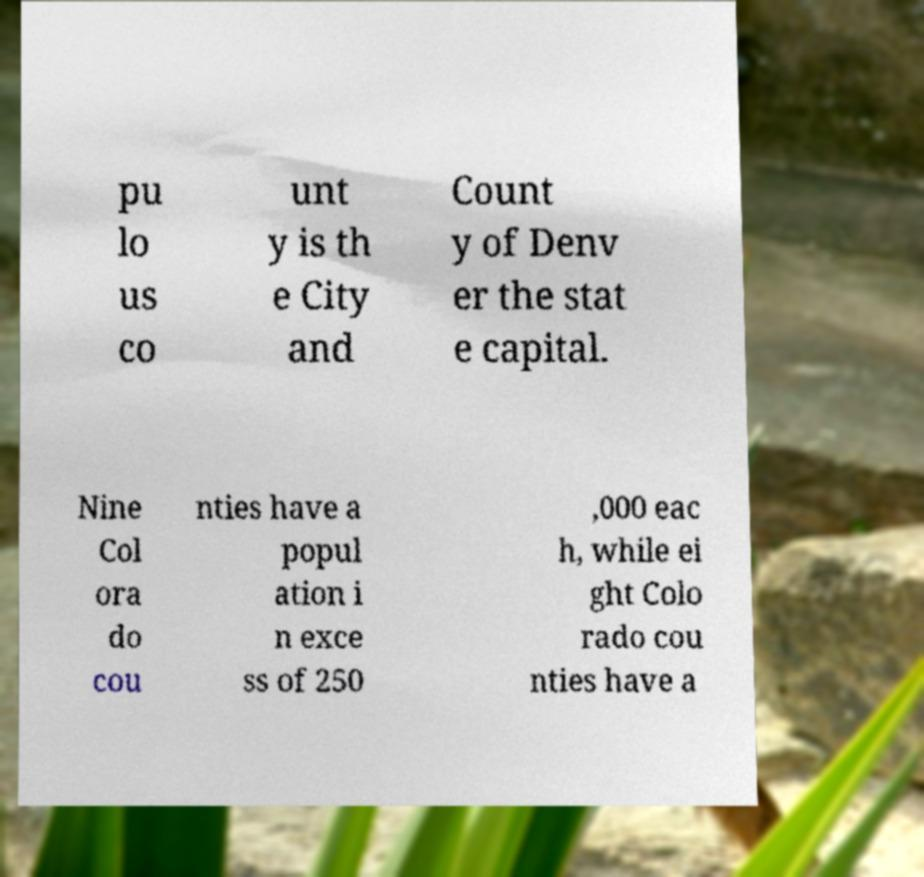Can you accurately transcribe the text from the provided image for me? pu lo us co unt y is th e City and Count y of Denv er the stat e capital. Nine Col ora do cou nties have a popul ation i n exce ss of 250 ,000 eac h, while ei ght Colo rado cou nties have a 